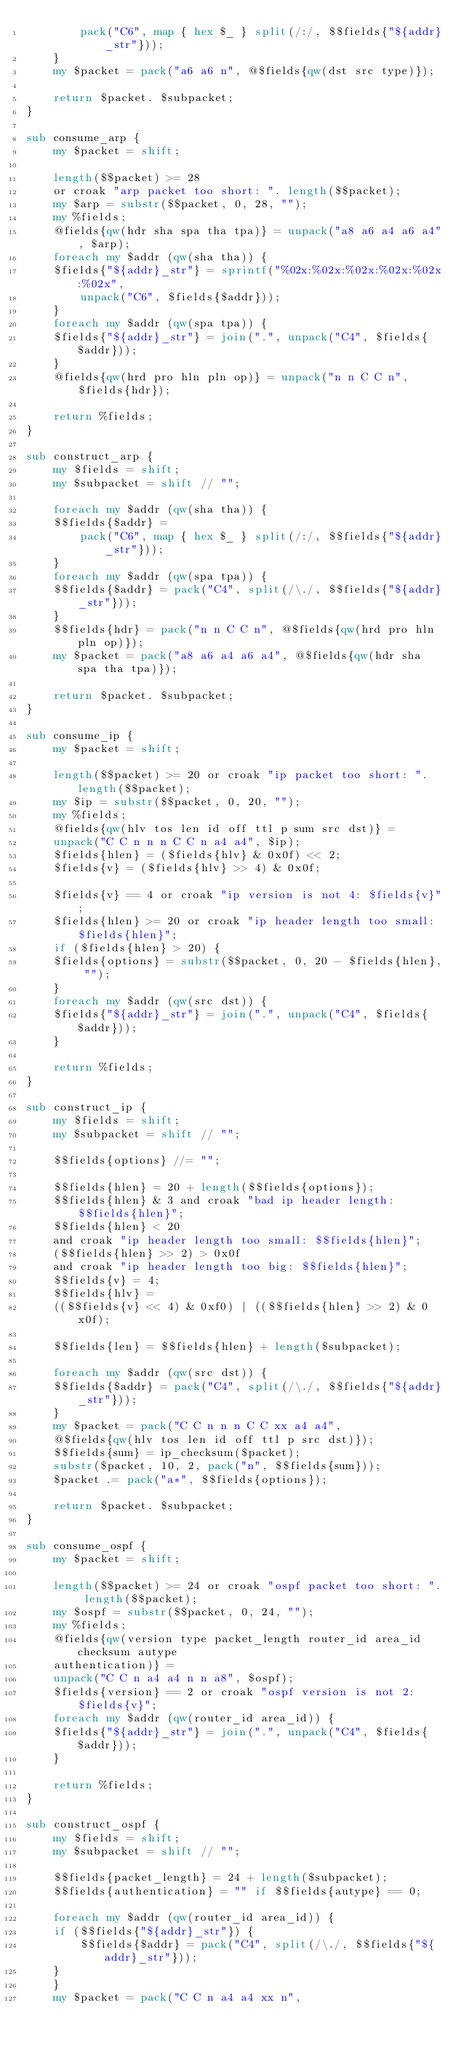<code> <loc_0><loc_0><loc_500><loc_500><_Perl_>	    pack("C6", map { hex $_ } split(/:/, $$fields{"${addr}_str"}));
    }
    my $packet = pack("a6 a6 n", @$fields{qw(dst src type)});

    return $packet. $subpacket;
}

sub consume_arp {
    my $packet = shift;

    length($$packet) >= 28
	or croak "arp packet too short: ". length($$packet);
    my $arp = substr($$packet, 0, 28, "");
    my %fields;
    @fields{qw(hdr sha spa tha tpa)} = unpack("a8 a6 a4 a6 a4", $arp);
    foreach my $addr (qw(sha tha)) {
	$fields{"${addr}_str"} = sprintf("%02x:%02x:%02x:%02x:%02x:%02x",
	    unpack("C6", $fields{$addr}));
    }
    foreach my $addr (qw(spa tpa)) {
	$fields{"${addr}_str"} = join(".", unpack("C4", $fields{$addr}));
    }
    @fields{qw(hrd pro hln pln op)} = unpack("n n C C n", $fields{hdr});

    return %fields;
}

sub construct_arp {
    my $fields = shift;
    my $subpacket = shift // "";

    foreach my $addr (qw(sha tha)) {
	$$fields{$addr} =
	    pack("C6", map { hex $_ } split(/:/, $$fields{"${addr}_str"}));
    }
    foreach my $addr (qw(spa tpa)) {
	$$fields{$addr} = pack("C4", split(/\./, $$fields{"${addr}_str"}));
    }
    $$fields{hdr} = pack("n n C C n", @$fields{qw(hrd pro hln pln op)});
    my $packet = pack("a8 a6 a4 a6 a4", @$fields{qw(hdr sha spa tha tpa)});

    return $packet. $subpacket;
}

sub consume_ip {
    my $packet = shift;

    length($$packet) >= 20 or croak "ip packet too short: ". length($$packet);
    my $ip = substr($$packet, 0, 20, "");
    my %fields;
    @fields{qw(hlv tos len id off ttl p sum src dst)} =
	unpack("C C n n n C C n a4 a4", $ip);
    $fields{hlen} = ($fields{hlv} & 0x0f) << 2;
    $fields{v} = ($fields{hlv} >> 4) & 0x0f;

    $fields{v} == 4 or croak "ip version is not 4: $fields{v}";
    $fields{hlen} >= 20 or croak "ip header length too small: $fields{hlen}";
    if ($fields{hlen} > 20) {
	$fields{options} = substr($$packet, 0, 20 - $fields{hlen}, "");
    }
    foreach my $addr (qw(src dst)) {
	$fields{"${addr}_str"} = join(".", unpack("C4", $fields{$addr}));
    }

    return %fields;
}

sub construct_ip {
    my $fields = shift;
    my $subpacket = shift // "";

    $$fields{options} //= "";

    $$fields{hlen} = 20 + length($$fields{options});
    $$fields{hlen} & 3 and croak "bad ip header length: $$fields{hlen}";
    $$fields{hlen} < 20
	and croak "ip header length too small: $$fields{hlen}";
    ($$fields{hlen} >> 2) > 0x0f
	and croak "ip header length too big: $$fields{hlen}";
    $$fields{v} = 4;
    $$fields{hlv} =
	(($$fields{v} << 4) & 0xf0) | (($$fields{hlen} >> 2) & 0x0f);

    $$fields{len} = $$fields{hlen} + length($subpacket);

    foreach my $addr (qw(src dst)) {
	$$fields{$addr} = pack("C4", split(/\./, $$fields{"${addr}_str"}));
    }
    my $packet = pack("C C n n n C C xx a4 a4",
	@$fields{qw(hlv tos len id off ttl p src dst)});
    $$fields{sum} = ip_checksum($packet);
    substr($packet, 10, 2, pack("n", $$fields{sum}));
    $packet .= pack("a*", $$fields{options});

    return $packet. $subpacket;
}

sub consume_ospf {
    my $packet = shift;

    length($$packet) >= 24 or croak "ospf packet too short: ". length($$packet);
    my $ospf = substr($$packet, 0, 24, "");
    my %fields;
    @fields{qw(version type packet_length router_id area_id checksum autype
	authentication)} =
	unpack("C C n a4 a4 n n a8", $ospf);
    $fields{version} == 2 or croak "ospf version is not 2: $fields{v}";
    foreach my $addr (qw(router_id area_id)) {
	$fields{"${addr}_str"} = join(".", unpack("C4", $fields{$addr}));
    }

    return %fields;
}

sub construct_ospf {
    my $fields = shift;
    my $subpacket = shift // "";

    $$fields{packet_length} = 24 + length($subpacket);
    $$fields{authentication} = "" if $$fields{autype} == 0;

    foreach my $addr (qw(router_id area_id)) {
	if ($$fields{"${addr}_str"}) {
	    $$fields{$addr} = pack("C4", split(/\./, $$fields{"${addr}_str"}));
	}
    }
    my $packet = pack("C C n a4 a4 xx n",</code> 